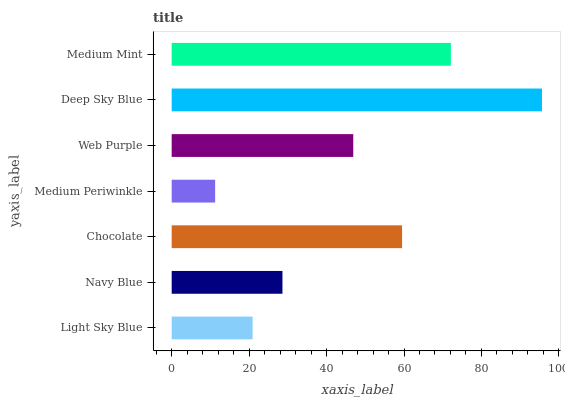Is Medium Periwinkle the minimum?
Answer yes or no. Yes. Is Deep Sky Blue the maximum?
Answer yes or no. Yes. Is Navy Blue the minimum?
Answer yes or no. No. Is Navy Blue the maximum?
Answer yes or no. No. Is Navy Blue greater than Light Sky Blue?
Answer yes or no. Yes. Is Light Sky Blue less than Navy Blue?
Answer yes or no. Yes. Is Light Sky Blue greater than Navy Blue?
Answer yes or no. No. Is Navy Blue less than Light Sky Blue?
Answer yes or no. No. Is Web Purple the high median?
Answer yes or no. Yes. Is Web Purple the low median?
Answer yes or no. Yes. Is Chocolate the high median?
Answer yes or no. No. Is Light Sky Blue the low median?
Answer yes or no. No. 